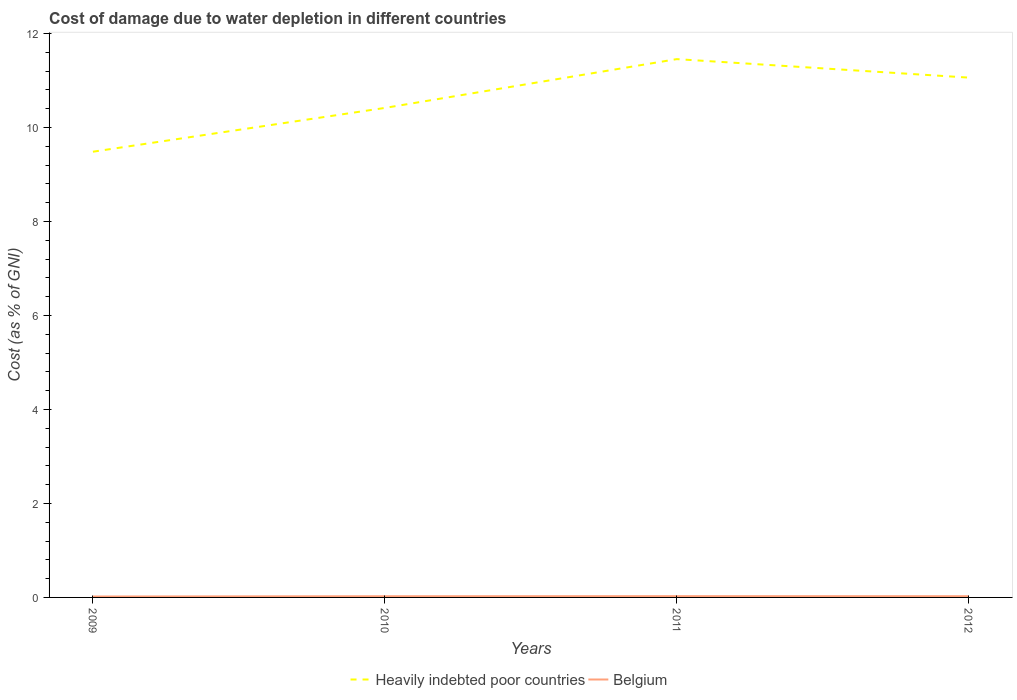How many different coloured lines are there?
Provide a succinct answer. 2. Is the number of lines equal to the number of legend labels?
Your response must be concise. Yes. Across all years, what is the maximum cost of damage caused due to water depletion in Heavily indebted poor countries?
Make the answer very short. 9.49. What is the total cost of damage caused due to water depletion in Belgium in the graph?
Offer a very short reply. -0.01. What is the difference between the highest and the second highest cost of damage caused due to water depletion in Belgium?
Offer a very short reply. 0.01. Is the cost of damage caused due to water depletion in Belgium strictly greater than the cost of damage caused due to water depletion in Heavily indebted poor countries over the years?
Make the answer very short. Yes. How many lines are there?
Offer a terse response. 2. How many years are there in the graph?
Offer a very short reply. 4. Does the graph contain any zero values?
Your answer should be very brief. No. Does the graph contain grids?
Give a very brief answer. No. How many legend labels are there?
Keep it short and to the point. 2. How are the legend labels stacked?
Your answer should be compact. Horizontal. What is the title of the graph?
Make the answer very short. Cost of damage due to water depletion in different countries. Does "Timor-Leste" appear as one of the legend labels in the graph?
Your answer should be compact. No. What is the label or title of the Y-axis?
Provide a short and direct response. Cost (as % of GNI). What is the Cost (as % of GNI) in Heavily indebted poor countries in 2009?
Provide a short and direct response. 9.49. What is the Cost (as % of GNI) in Belgium in 2009?
Provide a succinct answer. 0.02. What is the Cost (as % of GNI) of Heavily indebted poor countries in 2010?
Ensure brevity in your answer.  10.42. What is the Cost (as % of GNI) of Belgium in 2010?
Keep it short and to the point. 0.03. What is the Cost (as % of GNI) of Heavily indebted poor countries in 2011?
Your answer should be very brief. 11.46. What is the Cost (as % of GNI) in Belgium in 2011?
Keep it short and to the point. 0.03. What is the Cost (as % of GNI) of Heavily indebted poor countries in 2012?
Ensure brevity in your answer.  11.06. What is the Cost (as % of GNI) in Belgium in 2012?
Offer a terse response. 0.03. Across all years, what is the maximum Cost (as % of GNI) of Heavily indebted poor countries?
Give a very brief answer. 11.46. Across all years, what is the maximum Cost (as % of GNI) in Belgium?
Make the answer very short. 0.03. Across all years, what is the minimum Cost (as % of GNI) in Heavily indebted poor countries?
Give a very brief answer. 9.49. Across all years, what is the minimum Cost (as % of GNI) in Belgium?
Your response must be concise. 0.02. What is the total Cost (as % of GNI) of Heavily indebted poor countries in the graph?
Ensure brevity in your answer.  42.42. What is the total Cost (as % of GNI) in Belgium in the graph?
Give a very brief answer. 0.1. What is the difference between the Cost (as % of GNI) in Heavily indebted poor countries in 2009 and that in 2010?
Offer a terse response. -0.93. What is the difference between the Cost (as % of GNI) of Belgium in 2009 and that in 2010?
Give a very brief answer. -0.01. What is the difference between the Cost (as % of GNI) of Heavily indebted poor countries in 2009 and that in 2011?
Offer a very short reply. -1.97. What is the difference between the Cost (as % of GNI) in Belgium in 2009 and that in 2011?
Offer a terse response. -0.01. What is the difference between the Cost (as % of GNI) of Heavily indebted poor countries in 2009 and that in 2012?
Offer a terse response. -1.58. What is the difference between the Cost (as % of GNI) in Belgium in 2009 and that in 2012?
Keep it short and to the point. -0.01. What is the difference between the Cost (as % of GNI) in Heavily indebted poor countries in 2010 and that in 2011?
Provide a short and direct response. -1.04. What is the difference between the Cost (as % of GNI) of Belgium in 2010 and that in 2011?
Make the answer very short. -0. What is the difference between the Cost (as % of GNI) of Heavily indebted poor countries in 2010 and that in 2012?
Your answer should be compact. -0.65. What is the difference between the Cost (as % of GNI) in Belgium in 2010 and that in 2012?
Keep it short and to the point. -0. What is the difference between the Cost (as % of GNI) in Heavily indebted poor countries in 2011 and that in 2012?
Offer a terse response. 0.39. What is the difference between the Cost (as % of GNI) of Belgium in 2011 and that in 2012?
Provide a succinct answer. 0. What is the difference between the Cost (as % of GNI) of Heavily indebted poor countries in 2009 and the Cost (as % of GNI) of Belgium in 2010?
Your answer should be very brief. 9.46. What is the difference between the Cost (as % of GNI) in Heavily indebted poor countries in 2009 and the Cost (as % of GNI) in Belgium in 2011?
Provide a succinct answer. 9.46. What is the difference between the Cost (as % of GNI) in Heavily indebted poor countries in 2009 and the Cost (as % of GNI) in Belgium in 2012?
Your answer should be compact. 9.46. What is the difference between the Cost (as % of GNI) of Heavily indebted poor countries in 2010 and the Cost (as % of GNI) of Belgium in 2011?
Provide a short and direct response. 10.39. What is the difference between the Cost (as % of GNI) of Heavily indebted poor countries in 2010 and the Cost (as % of GNI) of Belgium in 2012?
Your answer should be very brief. 10.39. What is the difference between the Cost (as % of GNI) of Heavily indebted poor countries in 2011 and the Cost (as % of GNI) of Belgium in 2012?
Provide a succinct answer. 11.43. What is the average Cost (as % of GNI) of Heavily indebted poor countries per year?
Provide a short and direct response. 10.61. What is the average Cost (as % of GNI) of Belgium per year?
Keep it short and to the point. 0.02. In the year 2009, what is the difference between the Cost (as % of GNI) in Heavily indebted poor countries and Cost (as % of GNI) in Belgium?
Offer a very short reply. 9.47. In the year 2010, what is the difference between the Cost (as % of GNI) of Heavily indebted poor countries and Cost (as % of GNI) of Belgium?
Provide a short and direct response. 10.39. In the year 2011, what is the difference between the Cost (as % of GNI) of Heavily indebted poor countries and Cost (as % of GNI) of Belgium?
Make the answer very short. 11.43. In the year 2012, what is the difference between the Cost (as % of GNI) of Heavily indebted poor countries and Cost (as % of GNI) of Belgium?
Keep it short and to the point. 11.04. What is the ratio of the Cost (as % of GNI) of Heavily indebted poor countries in 2009 to that in 2010?
Your answer should be compact. 0.91. What is the ratio of the Cost (as % of GNI) in Belgium in 2009 to that in 2010?
Provide a succinct answer. 0.77. What is the ratio of the Cost (as % of GNI) of Heavily indebted poor countries in 2009 to that in 2011?
Give a very brief answer. 0.83. What is the ratio of the Cost (as % of GNI) in Belgium in 2009 to that in 2011?
Ensure brevity in your answer.  0.72. What is the ratio of the Cost (as % of GNI) of Heavily indebted poor countries in 2009 to that in 2012?
Give a very brief answer. 0.86. What is the ratio of the Cost (as % of GNI) in Belgium in 2009 to that in 2012?
Give a very brief answer. 0.75. What is the ratio of the Cost (as % of GNI) of Heavily indebted poor countries in 2010 to that in 2011?
Ensure brevity in your answer.  0.91. What is the ratio of the Cost (as % of GNI) of Belgium in 2010 to that in 2011?
Your response must be concise. 0.94. What is the ratio of the Cost (as % of GNI) of Heavily indebted poor countries in 2010 to that in 2012?
Your response must be concise. 0.94. What is the ratio of the Cost (as % of GNI) in Belgium in 2010 to that in 2012?
Offer a terse response. 0.98. What is the ratio of the Cost (as % of GNI) in Heavily indebted poor countries in 2011 to that in 2012?
Your answer should be very brief. 1.04. What is the ratio of the Cost (as % of GNI) in Belgium in 2011 to that in 2012?
Your answer should be compact. 1.04. What is the difference between the highest and the second highest Cost (as % of GNI) in Heavily indebted poor countries?
Provide a short and direct response. 0.39. What is the difference between the highest and the second highest Cost (as % of GNI) in Belgium?
Offer a terse response. 0. What is the difference between the highest and the lowest Cost (as % of GNI) of Heavily indebted poor countries?
Your answer should be very brief. 1.97. What is the difference between the highest and the lowest Cost (as % of GNI) in Belgium?
Your answer should be compact. 0.01. 